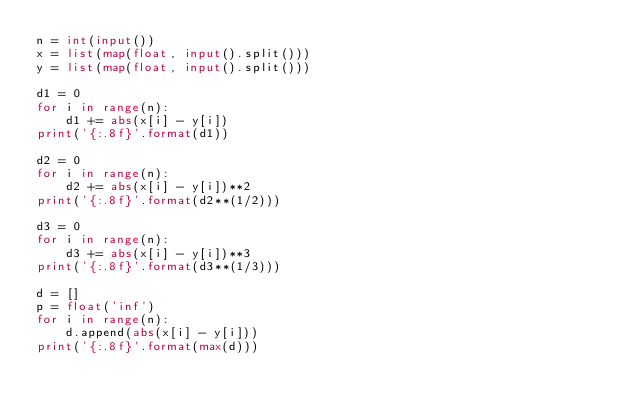Convert code to text. <code><loc_0><loc_0><loc_500><loc_500><_Python_>n = int(input())
x = list(map(float, input().split()))
y = list(map(float, input().split()))

d1 = 0
for i in range(n):
    d1 += abs(x[i] - y[i])
print('{:.8f}'.format(d1))

d2 = 0
for i in range(n):
    d2 += abs(x[i] - y[i])**2
print('{:.8f}'.format(d2**(1/2)))

d3 = 0
for i in range(n):
    d3 += abs(x[i] - y[i])**3
print('{:.8f}'.format(d3**(1/3)))

d = []
p = float('inf')
for i in range(n):
    d.append(abs(x[i] - y[i]))
print('{:.8f}'.format(max(d)))
</code> 